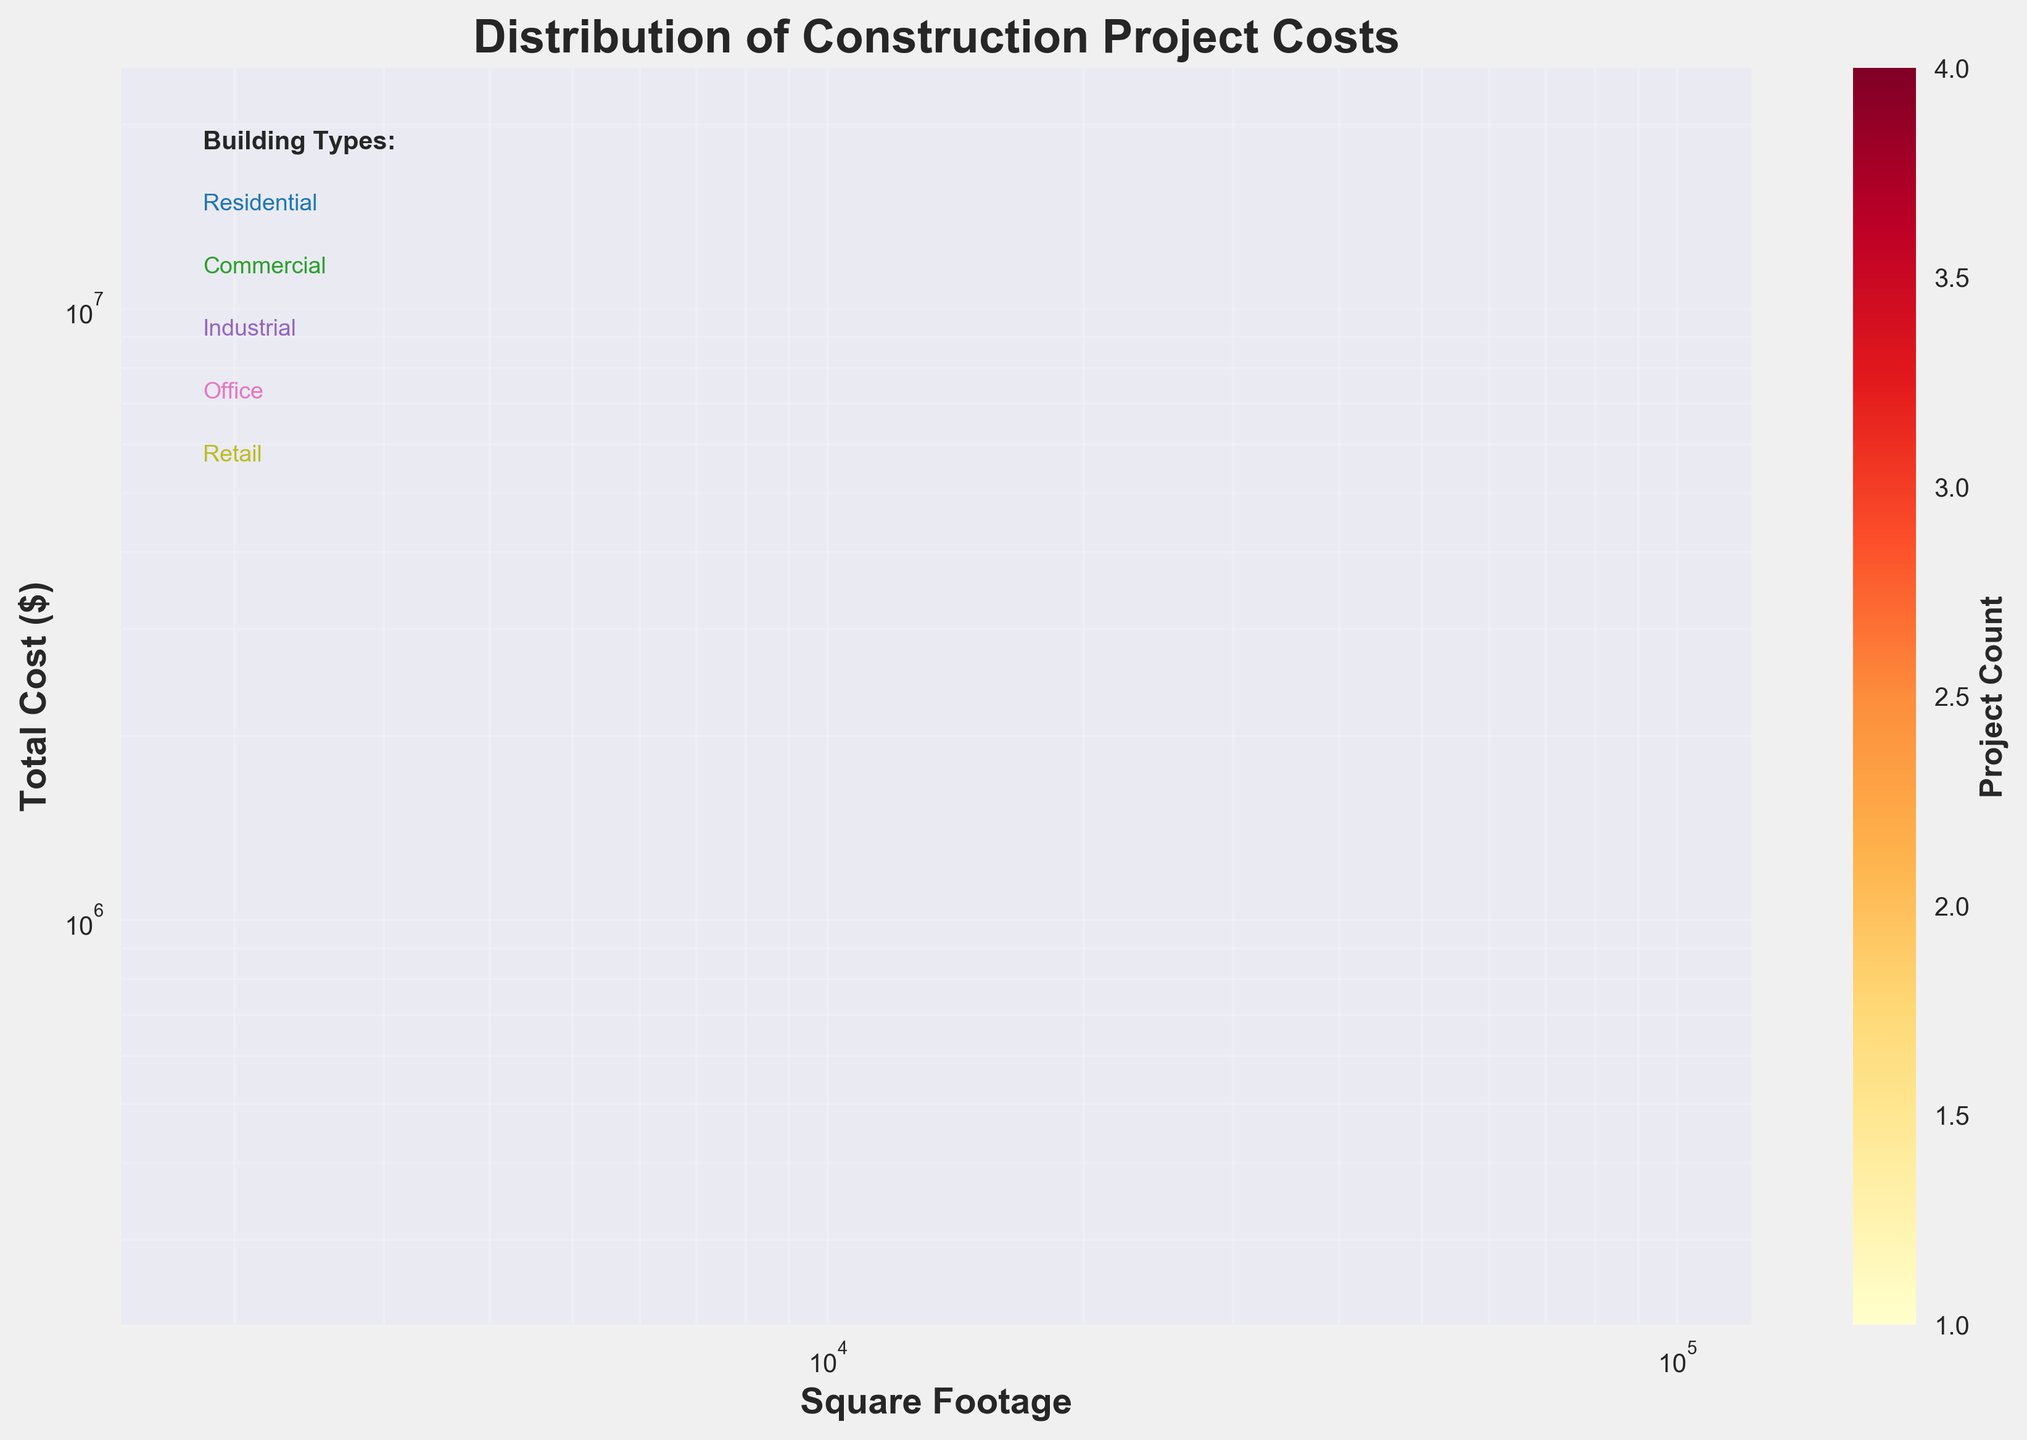How many building types are listed in the figure? The figure includes a section listing the unique building types present in the dataset. By reading this section, we see five building types mentioned.
Answer: Five What are the axes labeled in the figure? The x-axis is labeled 'Square Footage,' and the y-axis is labeled 'Total Cost ($)'. These labels indicate the metrics being plotted in the hexbin plot.
Answer: Square Footage and Total Cost ($) Which building type is associated with the highest values of square footage? Observing the figure, the building type 'Industrial' is associated with the highest square footage values as seen in the data section.
Answer: Industrial What color represents the highest density of data points in the plot? The color that represents the highest density of data points is indicated by the color bar. In the figure, the color mapped to higher densities is a dark shade near red.
Answer: Dark red Around which square footage range do most residential projects cluster? In the hexbin plot, we see a higher concentration of residential projects in the range of approximately 2000 to 3500 square footage.
Answer: 2000 to 3500 square footage Which building type projects have the highest total costs? 'Industrial' projects have the highest total costs, as observed from the data section and their distribution in the hexbin plot.
Answer: Industrial How do the total costs of office projects compare to those of retail projects? Office projects generally have higher total costs compared to retail projects, evident from the plot where office projects are more spread towards higher cost areas than retail.
Answer: Higher What building type shows the widest range in square footage in the plot? The 'Commercial' building type shows a wide range in square footage, evident from its spread across a large section of the x-axis in the plot.
Answer: Commercial Is the distribution of square footage larger for Retail or Residential projects? The distribution of square footage range for retail projects is smaller compared to residential projects, as observed by the narrower spread of Retail projects on the x-axis.
Answer: Residential What's the average square footage of office projects if the plot data indicates clustering around the square footages of 10000, 18000, and 25000? To find the average, add these values and divide by 3: (10000 + 18000 + 25000) / 3 = 53000 / 3 = approximately 17667.
Answer: 17667 square feet 